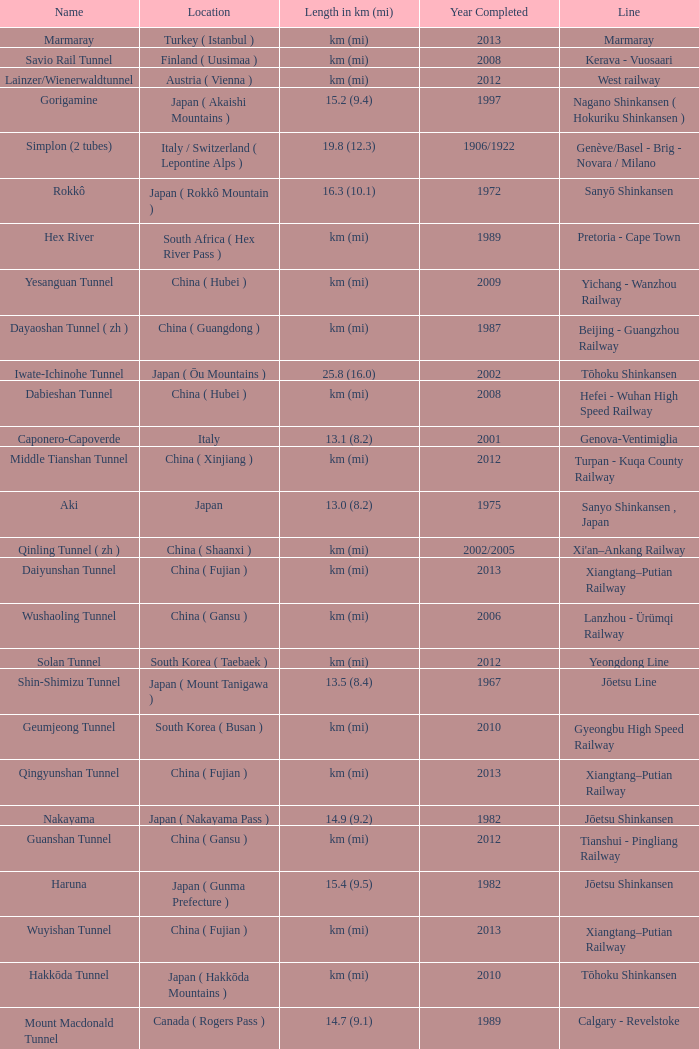Which line is the Geumjeong tunnel? Gyeongbu High Speed Railway. 